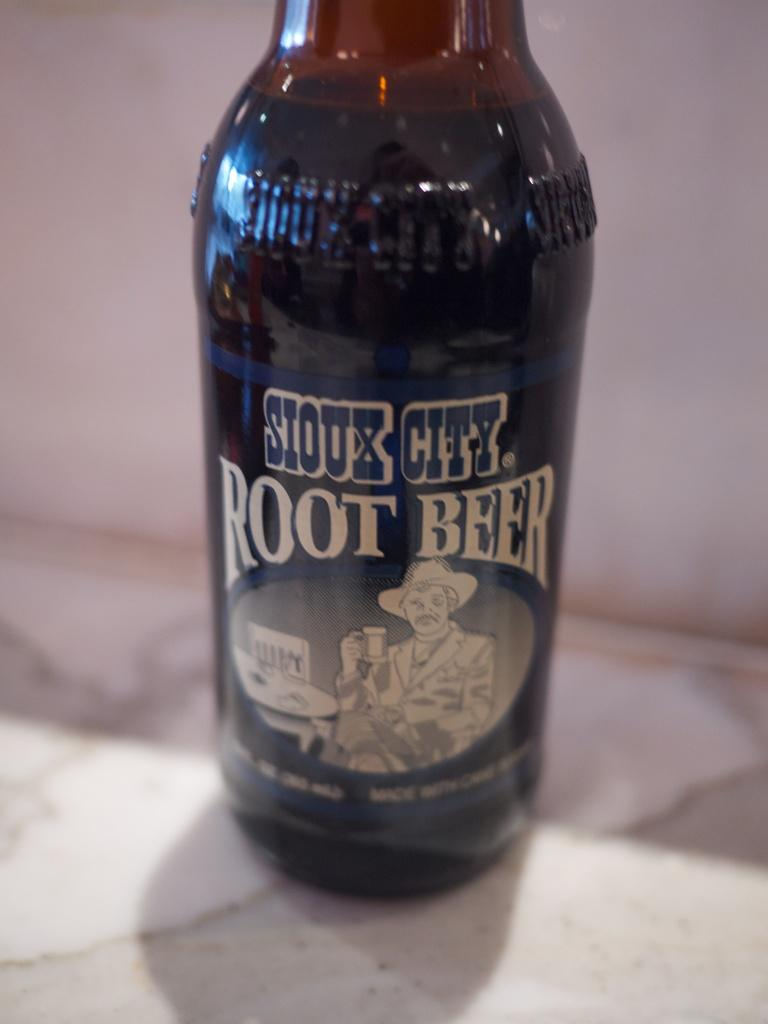<image>
Summarize the visual content of the image. A bottle of Sioux City root beer has a blue an white label. 